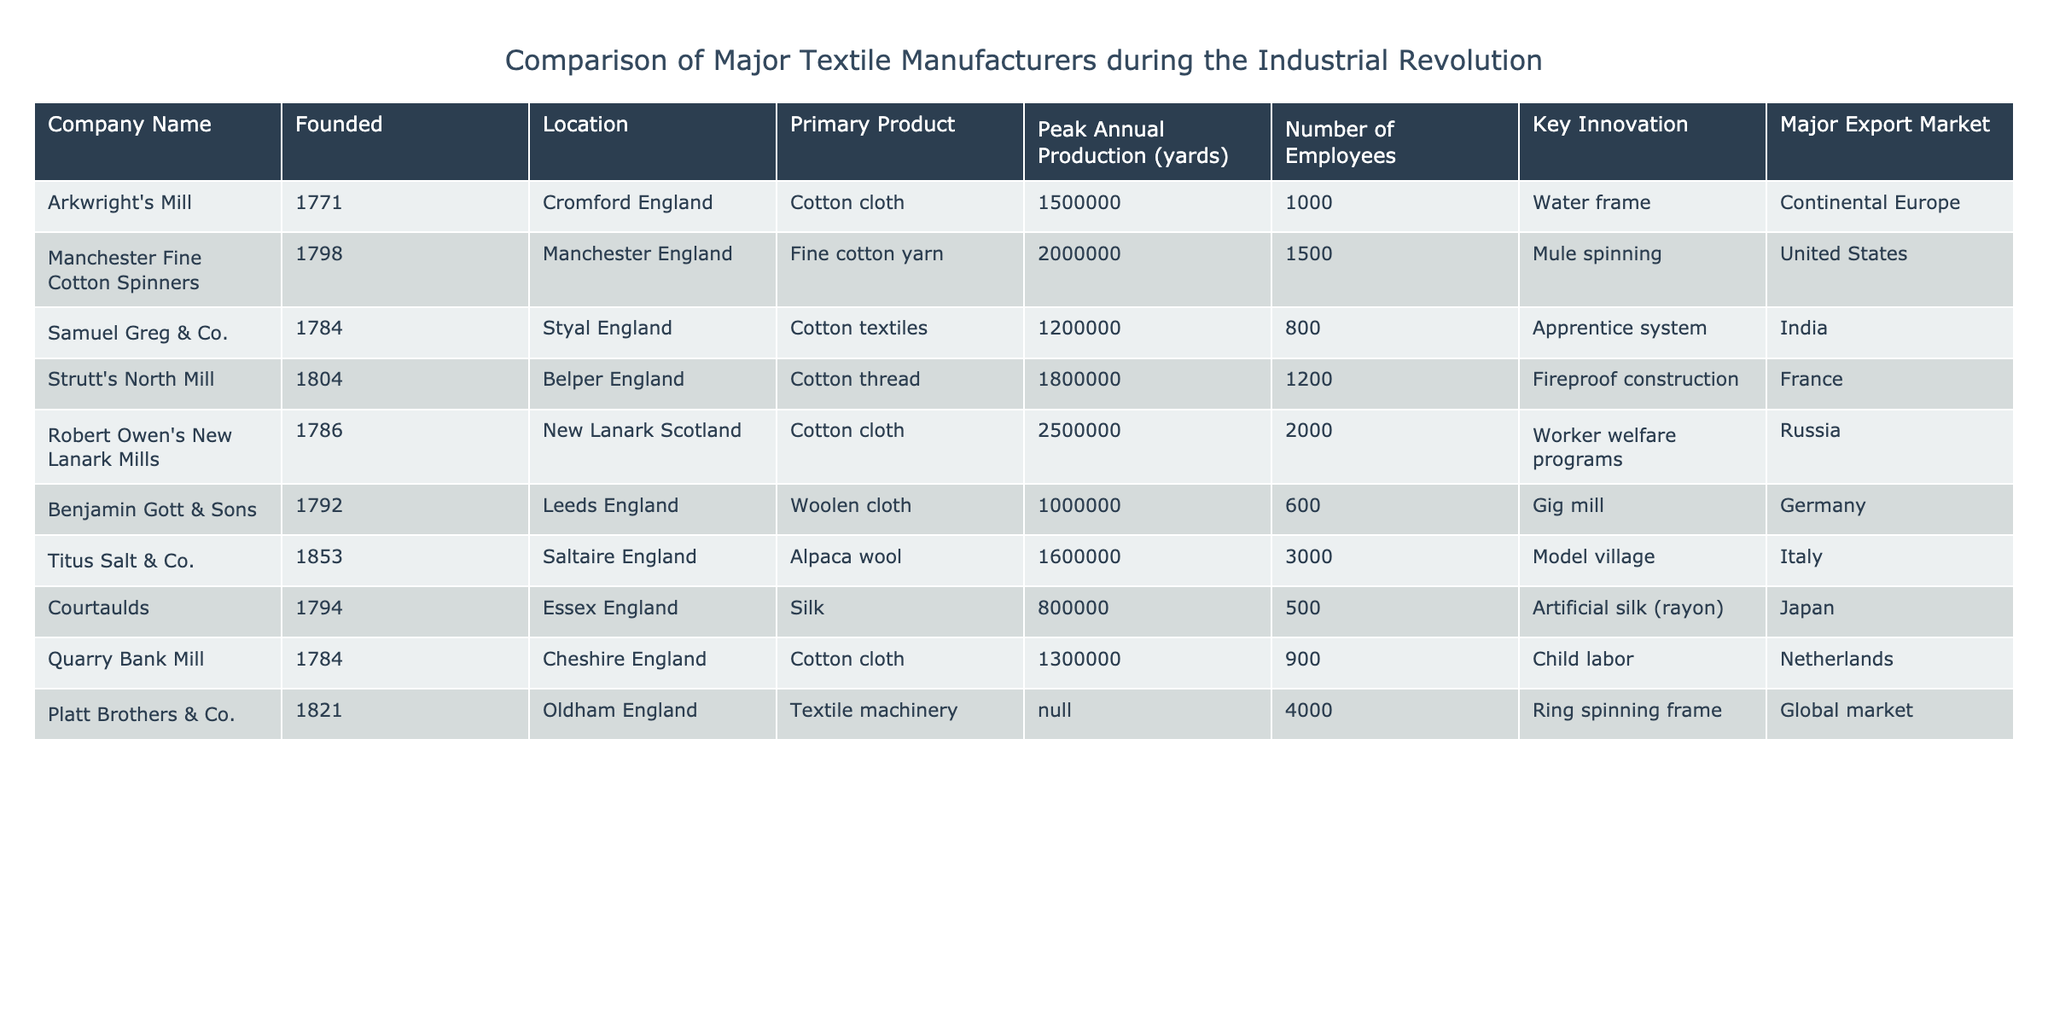What is the peak annual production of Robert Owen's New Lanark Mills? The peak annual production of Robert Owen's New Lanark Mills is explicitly listed in the table as 2,500,000 yards of cotton cloth.
Answer: 2,500,000 yards Which company has the highest number of employees, and how many do they have? The company with the highest number of employees is Titus Salt & Co., which has 3,000 employees, as indicated in the "Number of Employees" column.
Answer: Titus Salt & Co., 3000 What is the average peak annual production of the companies listed in the table? To find the average peak annual production, we sum the peak productions: 1,500,000 + 2,000,000 + 1,200,000 + 1,800,000 + 2,500,000 + 1,000,000 + 1,600,000 + 800,000 + 1,300,000 = 12,700,000. There are 9 companies, so the average is 12,700,000 / 9 = approximately 1,411,111.
Answer: 1,411,111 yards Is Courtaulds located in England? The table indicates that Courtaulds is located in Essex, England, which confirms that the statement is true.
Answer: Yes Which company had a major export market in India and what was its primary product? The company that had a major export market in India is Samuel Greg & Co., and its primary product is cotton textiles, as shown in the respective columns for that company.
Answer: Samuel Greg & Co., cotton textiles What innovation was introduced by Platt Brothers & Co.? The innovation introduced by Platt Brothers & Co. is the ring spinning frame, as stated in the "Key Innovation" column for that company.
Answer: Ring spinning frame How many companies produced cotton cloth, and what are their names? Looking through the table, the companies that produced cotton cloth are Arkwright's Mill, Robert Owen's New Lanark Mills, Strutt's North Mill, and Quarry Bank Mill, totaling four companies.
Answer: 4 companies: Arkwright's Mill, Robert Owen's New Lanark Mills, Strutt's North Mill, Quarry Bank Mill Was the primary product of Benjamin Gott & Sons woolen cloth? The table shows that the primary product of Benjamin Gott & Sons is woolen cloth, which confirms that the statement is true.
Answer: Yes 